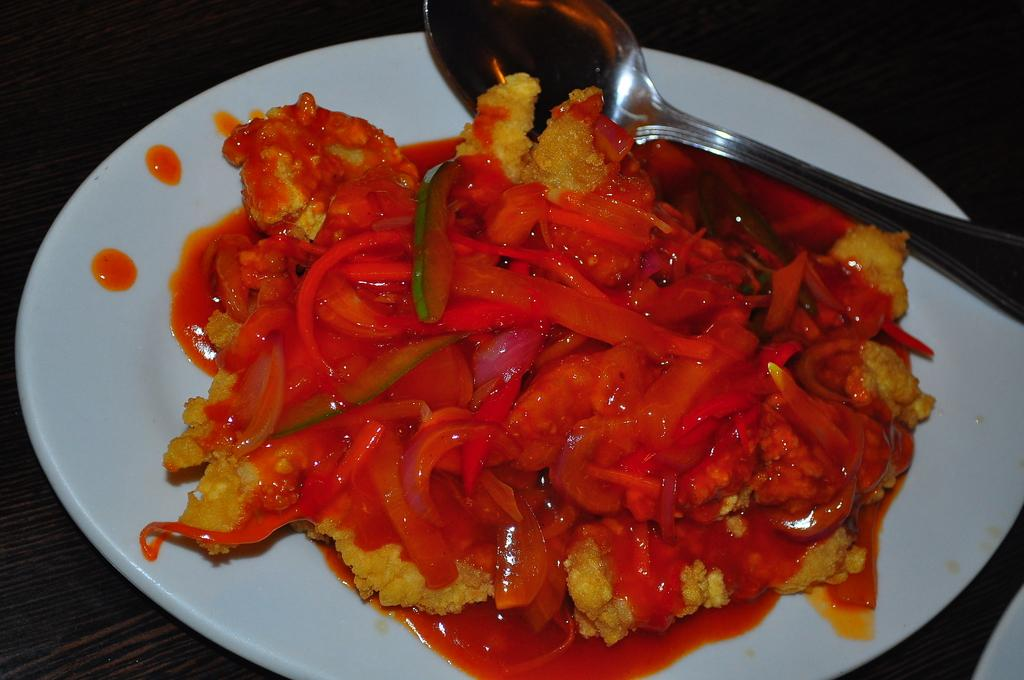What type of objects can be seen in the image? There are food items and a spoon on a plate in the image. Can you describe the spoon's location in the image? The spoon is on a plate in the image. What is present in the bottom right corner of the image? There is a white object in the bottom right corner of the image. What type of bells can be heard ringing in the image? There are no bells present in the image, and therefore no sound can be heard. 